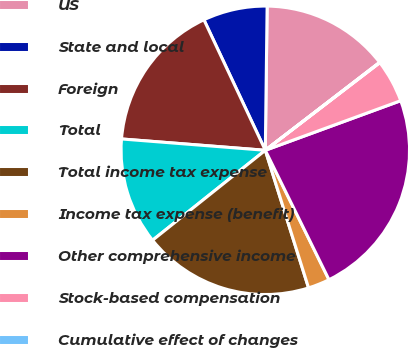Convert chart. <chart><loc_0><loc_0><loc_500><loc_500><pie_chart><fcel>US<fcel>State and local<fcel>Foreign<fcel>Total<fcel>Total income tax expense<fcel>Income tax expense (benefit)<fcel>Other comprehensive income<fcel>Stock-based compensation<fcel>Cumulative effect of changes<nl><fcel>14.36%<fcel>7.2%<fcel>16.75%<fcel>11.97%<fcel>19.13%<fcel>2.43%<fcel>23.31%<fcel>4.81%<fcel>0.04%<nl></chart> 